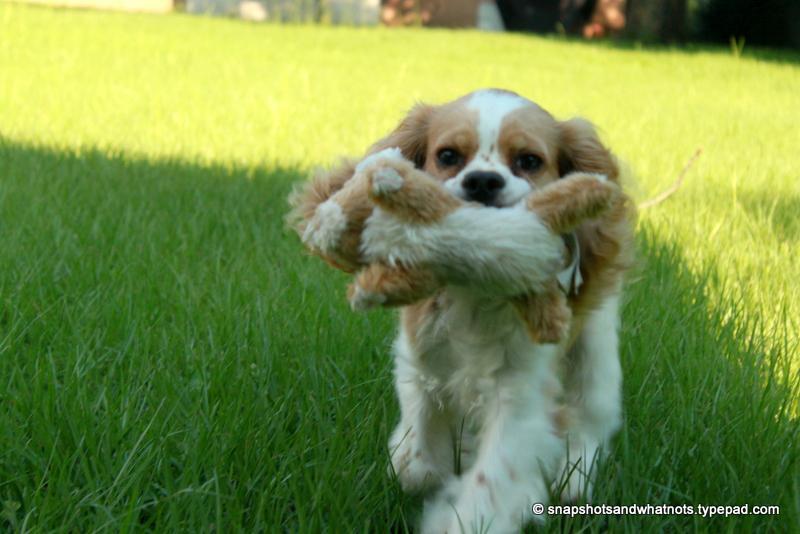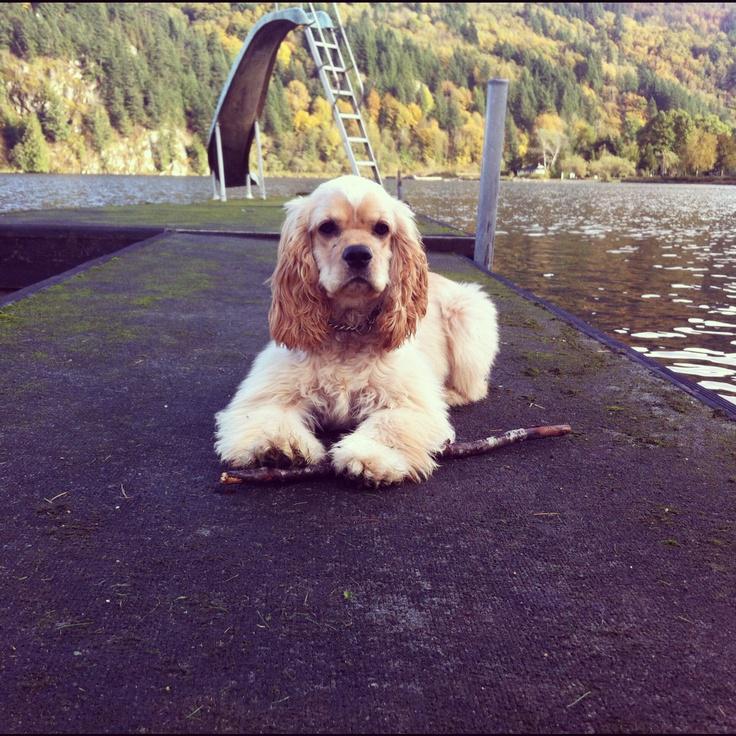The first image is the image on the left, the second image is the image on the right. Considering the images on both sides, is "The dog in the right image is lying down on the ground." valid? Answer yes or no. Yes. The first image is the image on the left, the second image is the image on the right. Analyze the images presented: Is the assertion "In the left image, there's a dog running through the grass while carrying something in its mouth." valid? Answer yes or no. Yes. 